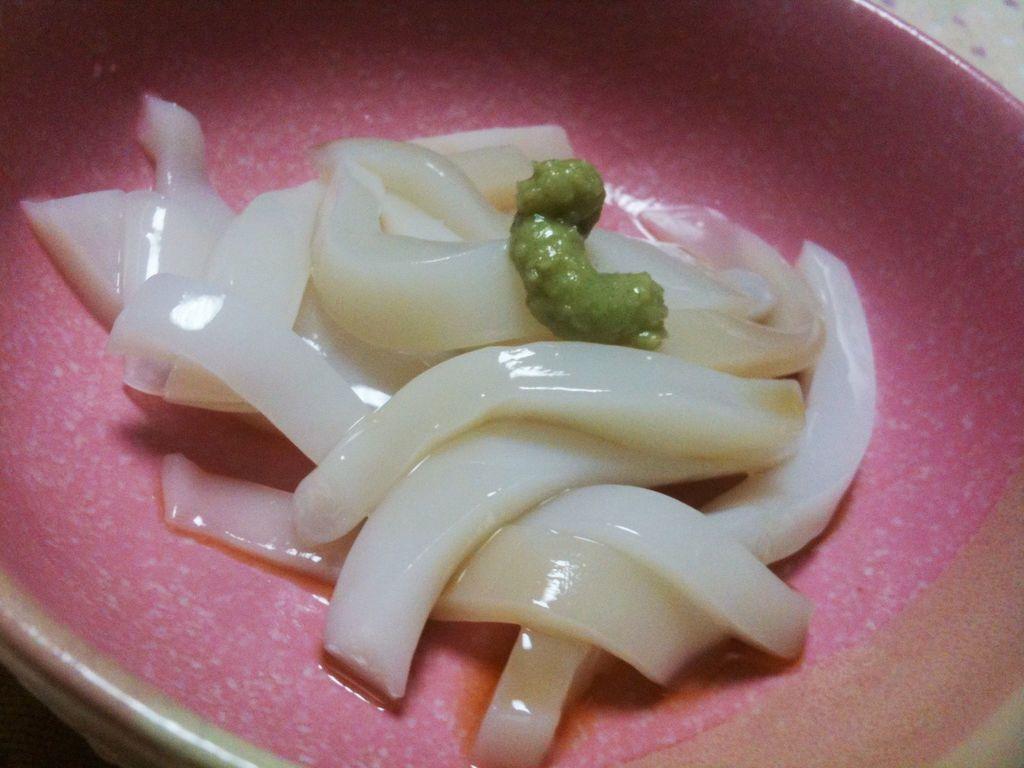Could you give a brief overview of what you see in this image? In this image, we can see some food item in a container. We can also see an object on the top right corner. 